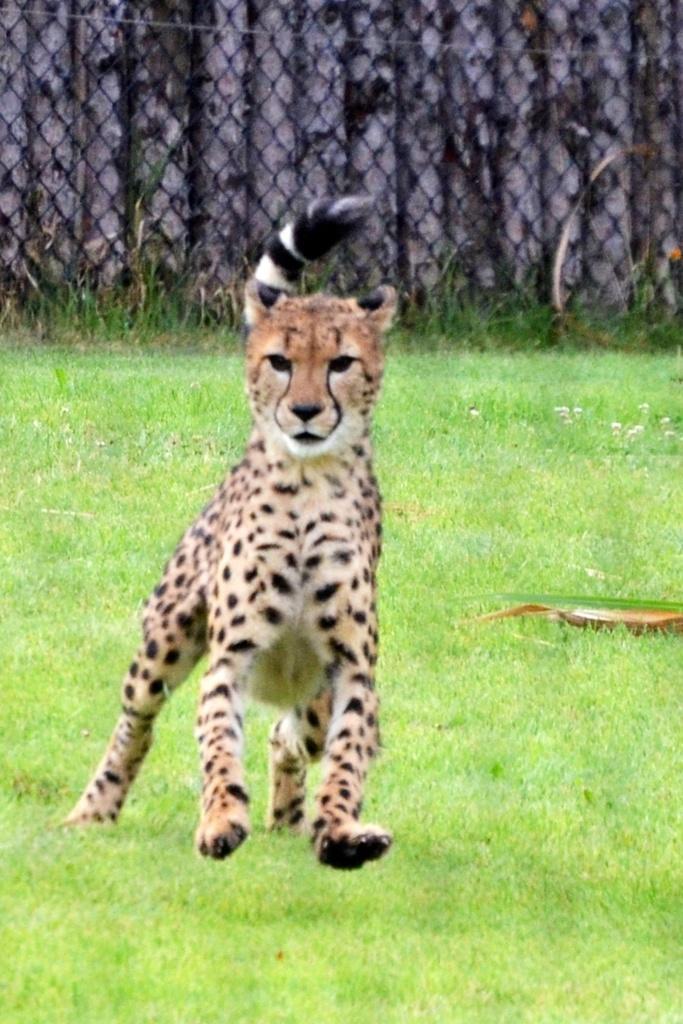Can you describe this image briefly? In this image, we can see a cheetah is running on the grass. At the top of the image, we can see the mesh. Through the mesh we can see wooden poles. 